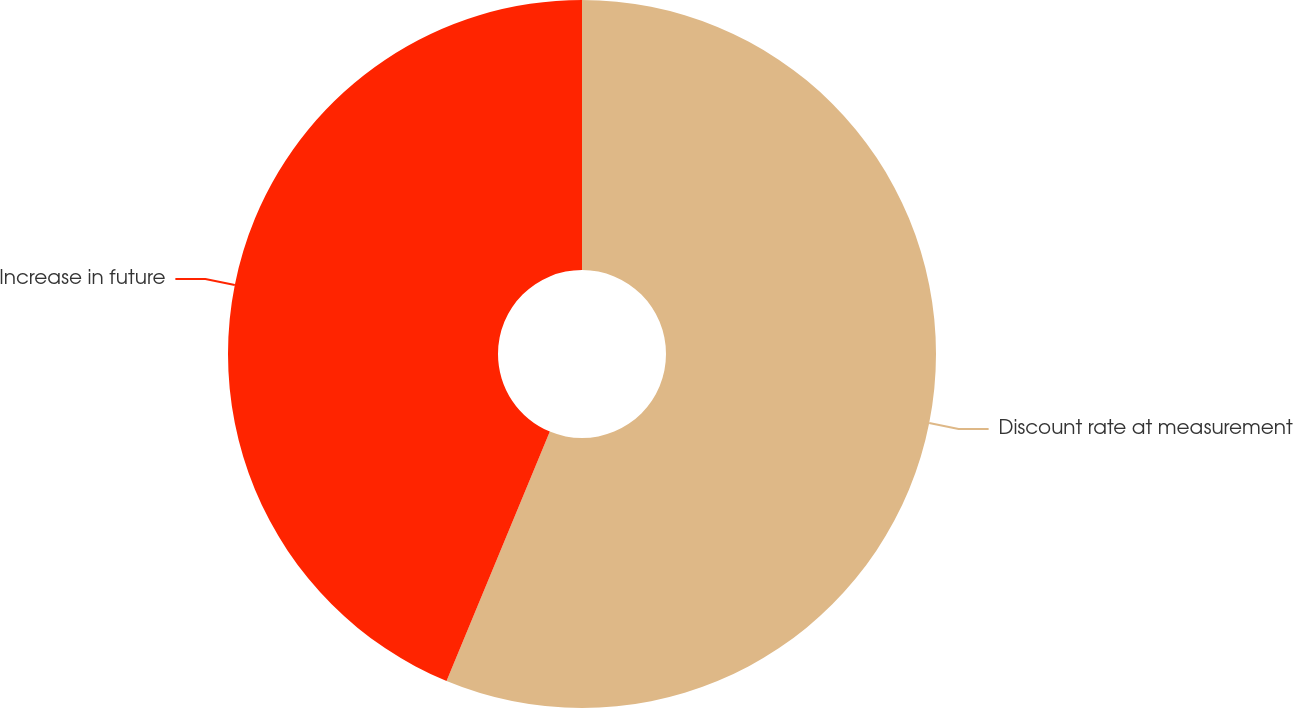Convert chart. <chart><loc_0><loc_0><loc_500><loc_500><pie_chart><fcel>Discount rate at measurement<fcel>Increase in future<nl><fcel>56.25%<fcel>43.75%<nl></chart> 